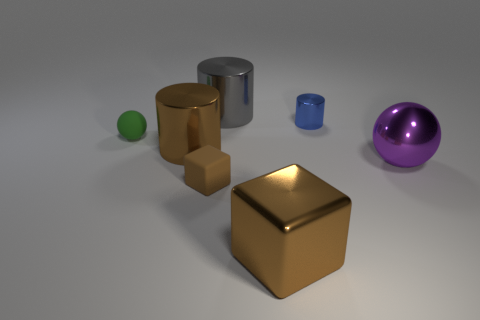What is the size of the other thing that is the same shape as the tiny green rubber thing?
Your answer should be compact. Large. What number of other rubber blocks are the same color as the large cube?
Provide a succinct answer. 1. Are there any green objects that have the same size as the gray cylinder?
Your response must be concise. No. There is a sphere right of the small cylinder; what is it made of?
Your answer should be very brief. Metal. Are the big object behind the small blue shiny object and the tiny blue cylinder made of the same material?
Provide a succinct answer. Yes. Are there any small purple matte cylinders?
Your answer should be very brief. No. What color is the tiny object that is made of the same material as the tiny green sphere?
Offer a very short reply. Brown. There is a object left of the large cylinder on the left side of the large cylinder that is behind the small cylinder; what is its color?
Offer a terse response. Green. There is a matte cube; is it the same size as the rubber thing behind the tiny brown rubber cube?
Offer a very short reply. Yes. How many things are brown blocks to the right of the gray cylinder or big objects that are behind the small green ball?
Your answer should be very brief. 2. 